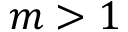Convert formula to latex. <formula><loc_0><loc_0><loc_500><loc_500>m > 1</formula> 